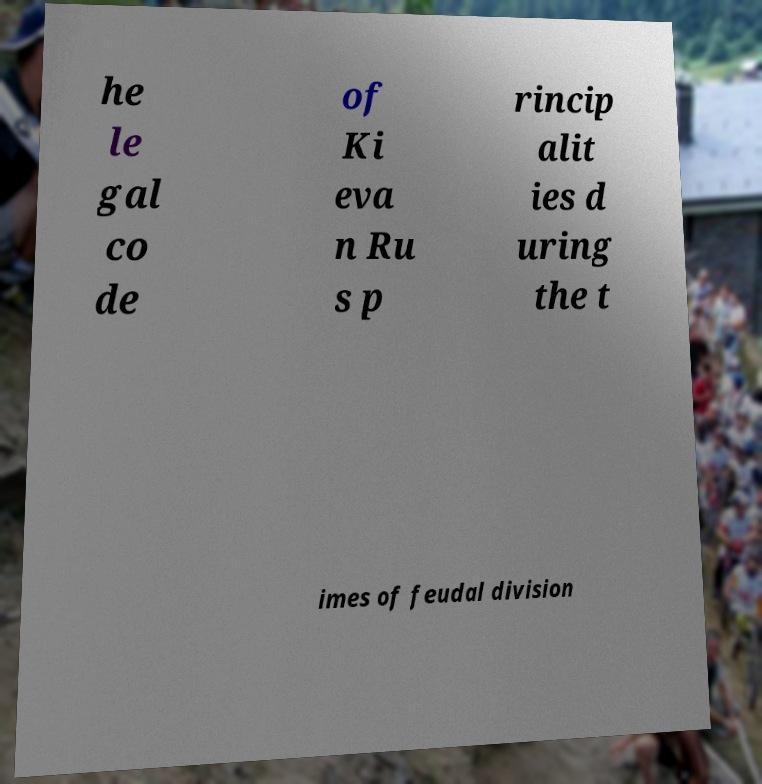Could you assist in decoding the text presented in this image and type it out clearly? he le gal co de of Ki eva n Ru s p rincip alit ies d uring the t imes of feudal division 